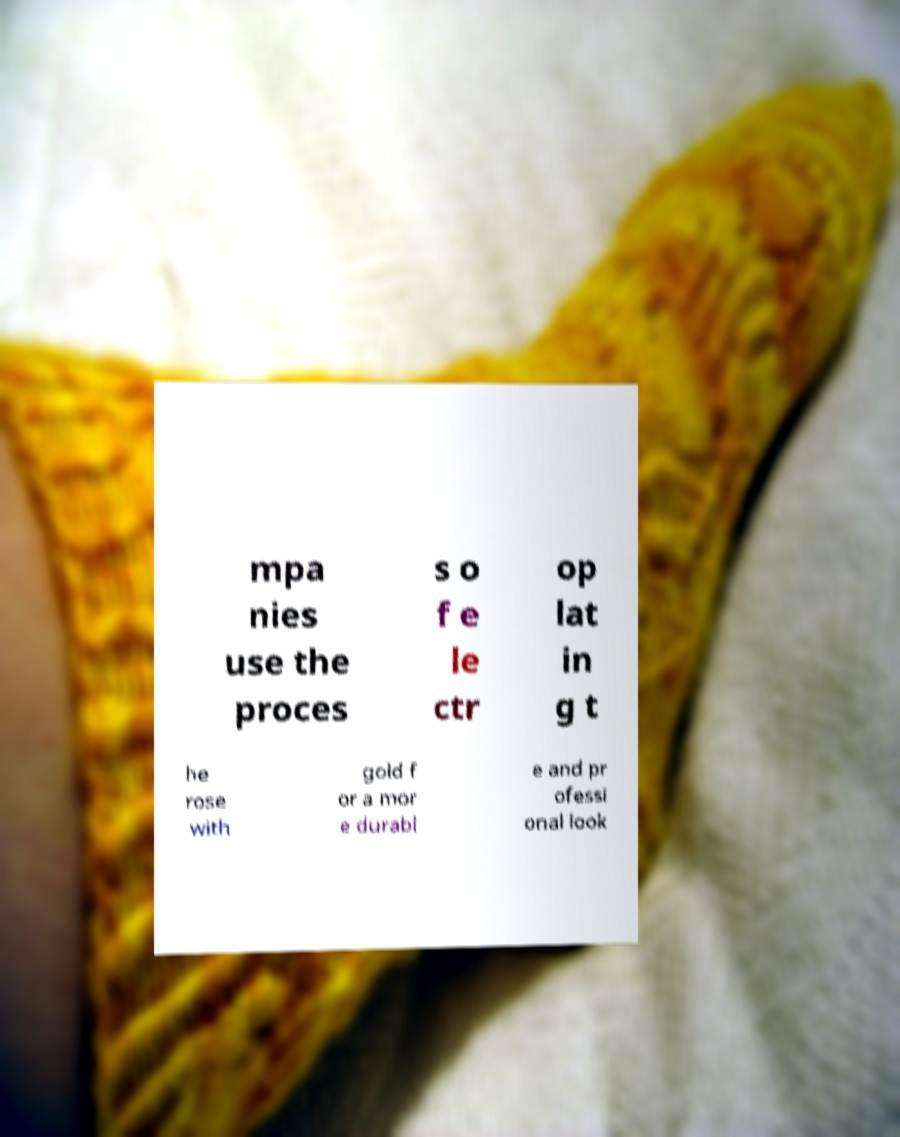For documentation purposes, I need the text within this image transcribed. Could you provide that? mpa nies use the proces s o f e le ctr op lat in g t he rose with gold f or a mor e durabl e and pr ofessi onal look 